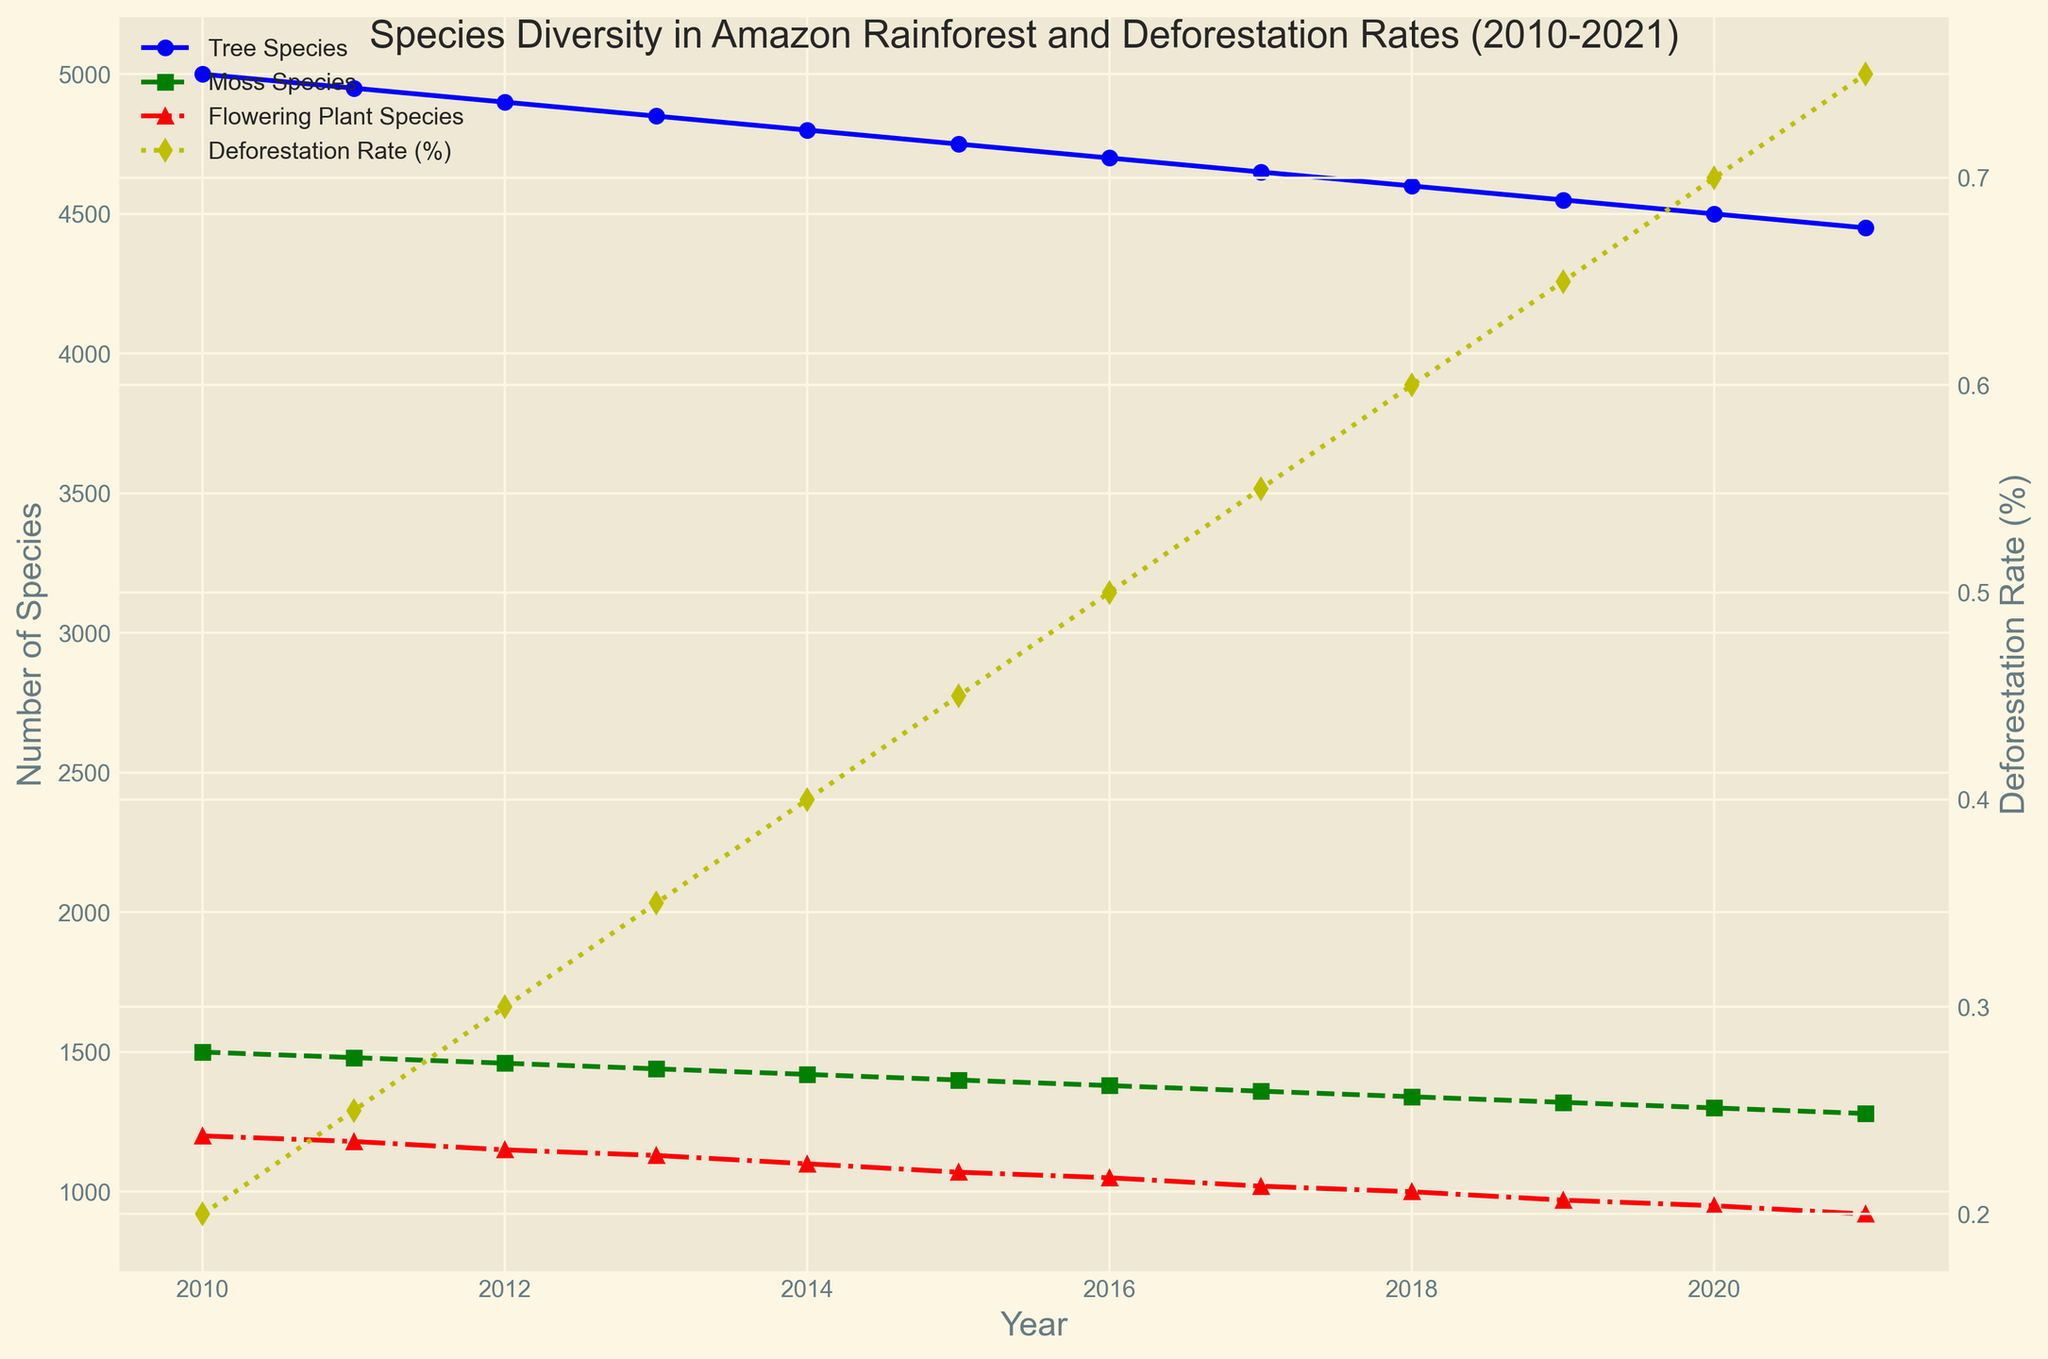What is the trend in the number of Tree Species from 2010 to 2021? The plot graph shows a steady decline in the number of Tree Species from 5000 in 2010 to 4450 in 2021. Simply observe the downward trend in connection points.
Answer: Steady decline Which year shows the highest Deforestation Rate? The plot graph for Deforestation Rate (%) shows that it peaks in 2021. This is identified by the highest data point in the yellow dotted line.
Answer: 2021 Compare the number of Moss Species and Flowering Plant Species in 2015. Which is higher, and by how much? From the figure, in 2015, Moss Species are 1400 and Flowering Plant Species are 1070. Calculating the difference: 1400 - 1070 = 330. Moss Species are higher by 330.
Answer: Moss Species; higher by 330 What is the overall trend in the Deforestation Rate (%) over the decade? By observing the trend line (yellow dotted line) for Deforestation Rate (%), it shows a consistent upward trend from 0.2% in 2010 to 0.75% in 2021.
Answer: Consistent upward trend How does the decrease in Tree Species from 2010 to 2021 compare to the change in Flowering Plant Species over the same period? The number of Tree Species decreased from 5000 to 4450, a decrease of 500. The number of Flowering Plant Species decreased from 1200 to 920, a decrease of 280.
Answer: Tree Species decrease = 550, Flowering Plant Species decrease = 280 What's the average Deforestation Rate over the decade between 2010 to 2021? Sum of Deforestation Rates from 2010 to 2021 is 0.2 + 0.25 + 0.3 + 0.35 + 0.4 + 0.45 + 0.5 + 0.55 + 0.6 + 0.65 + 0.7 + 0.75 = 5.65. Now dividing by the number of years (12): 5.65 / 12 = 0.471. The average Deforestation Rate is approximately 0.471%
Answer: ~0.471% In which year do Flowering Plant Species reach their lowest number within the shown timeline? From the plot, the lowest point in the red dotted line representing Flowering Plant Species is in 2021, with a value of 920.
Answer: 2021 Calculate the rate of decrease in Moss Species between 2013 and 2016. Number of Moss Species in 2013 is 1440, and in 2016 is 1380. The difference is 1440 - 1380 = 60. The decrease over the 3 years is 60. Dividing this by 3 gives the rate: 60/3 = 20 species per year.
Answer: 20 species per year 